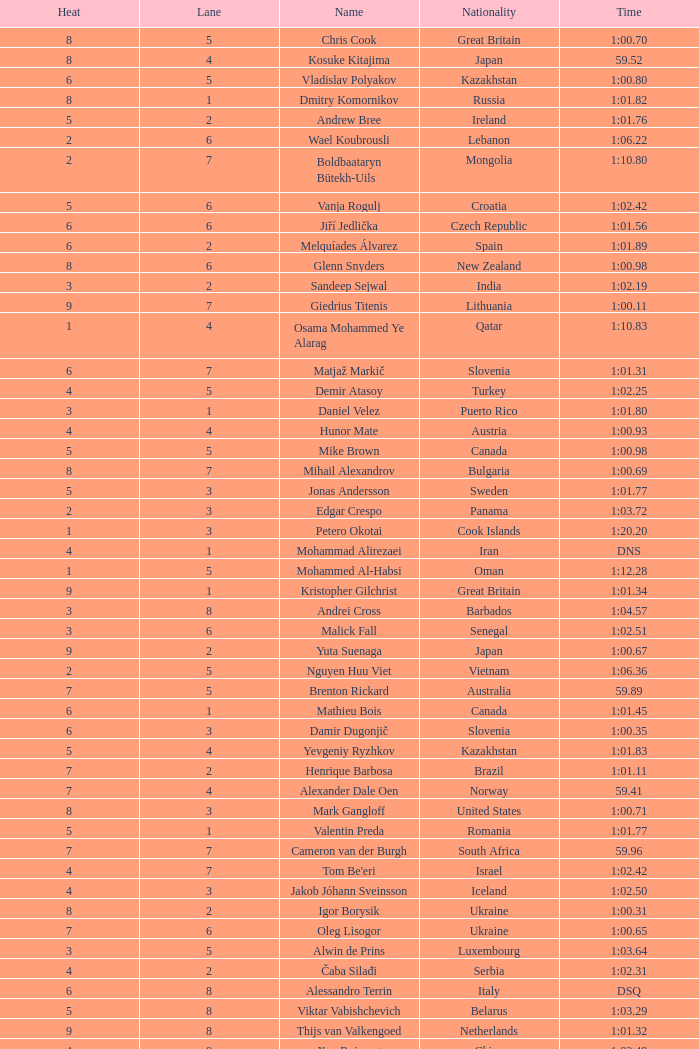What is the smallest lane number of Xue Ruipeng? 8.0. 